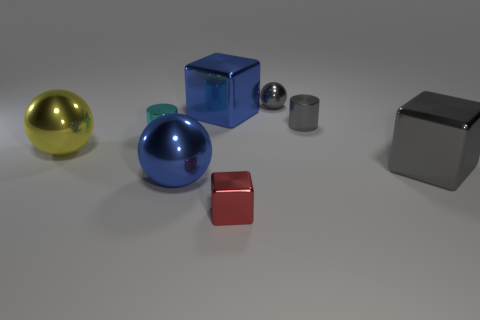Add 2 tiny cyan metallic objects. How many objects exist? 10 Subtract all spheres. How many objects are left? 5 Add 4 big rubber cylinders. How many big rubber cylinders exist? 4 Subtract 0 cyan cubes. How many objects are left? 8 Subtract all green blocks. Subtract all tiny cylinders. How many objects are left? 6 Add 7 gray cylinders. How many gray cylinders are left? 8 